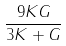<formula> <loc_0><loc_0><loc_500><loc_500>\frac { 9 K G } { 3 K + G }</formula> 